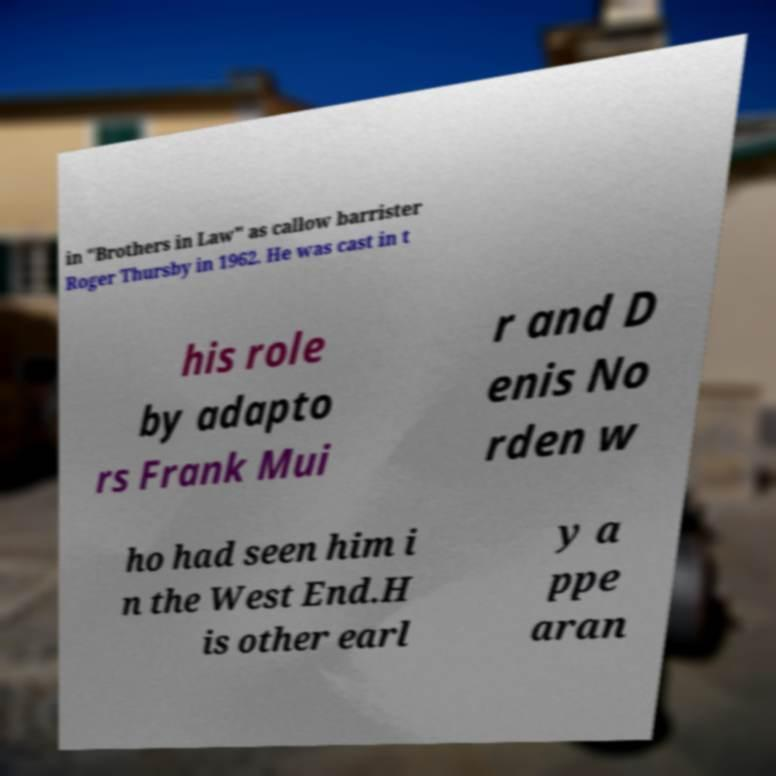Please identify and transcribe the text found in this image. in "Brothers in Law" as callow barrister Roger Thursby in 1962. He was cast in t his role by adapto rs Frank Mui r and D enis No rden w ho had seen him i n the West End.H is other earl y a ppe aran 